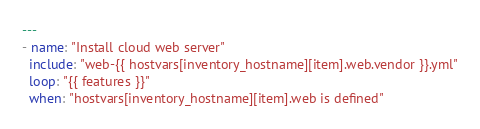<code> <loc_0><loc_0><loc_500><loc_500><_YAML_>---
- name: "Install cloud web server"
  include: "web-{{ hostvars[inventory_hostname][item].web.vendor }}.yml"
  loop: "{{ features }}"
  when: "hostvars[inventory_hostname][item].web is defined"

</code> 